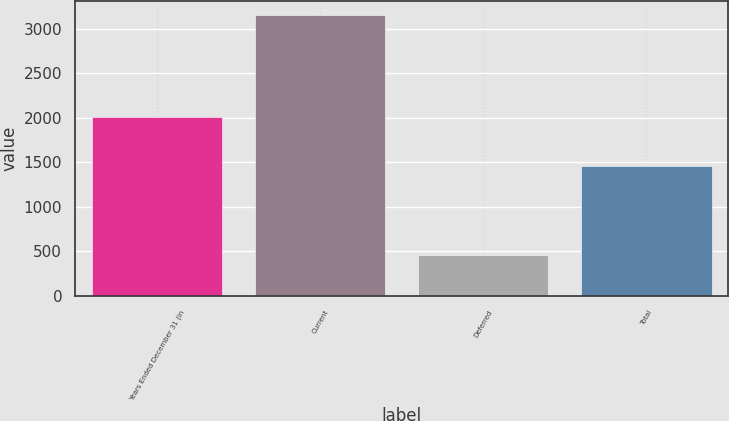Convert chart to OTSL. <chart><loc_0><loc_0><loc_500><loc_500><bar_chart><fcel>Years Ended December 31 (in<fcel>Current<fcel>Deferred<fcel>Total<nl><fcel>2007<fcel>3157<fcel>461<fcel>1455<nl></chart> 